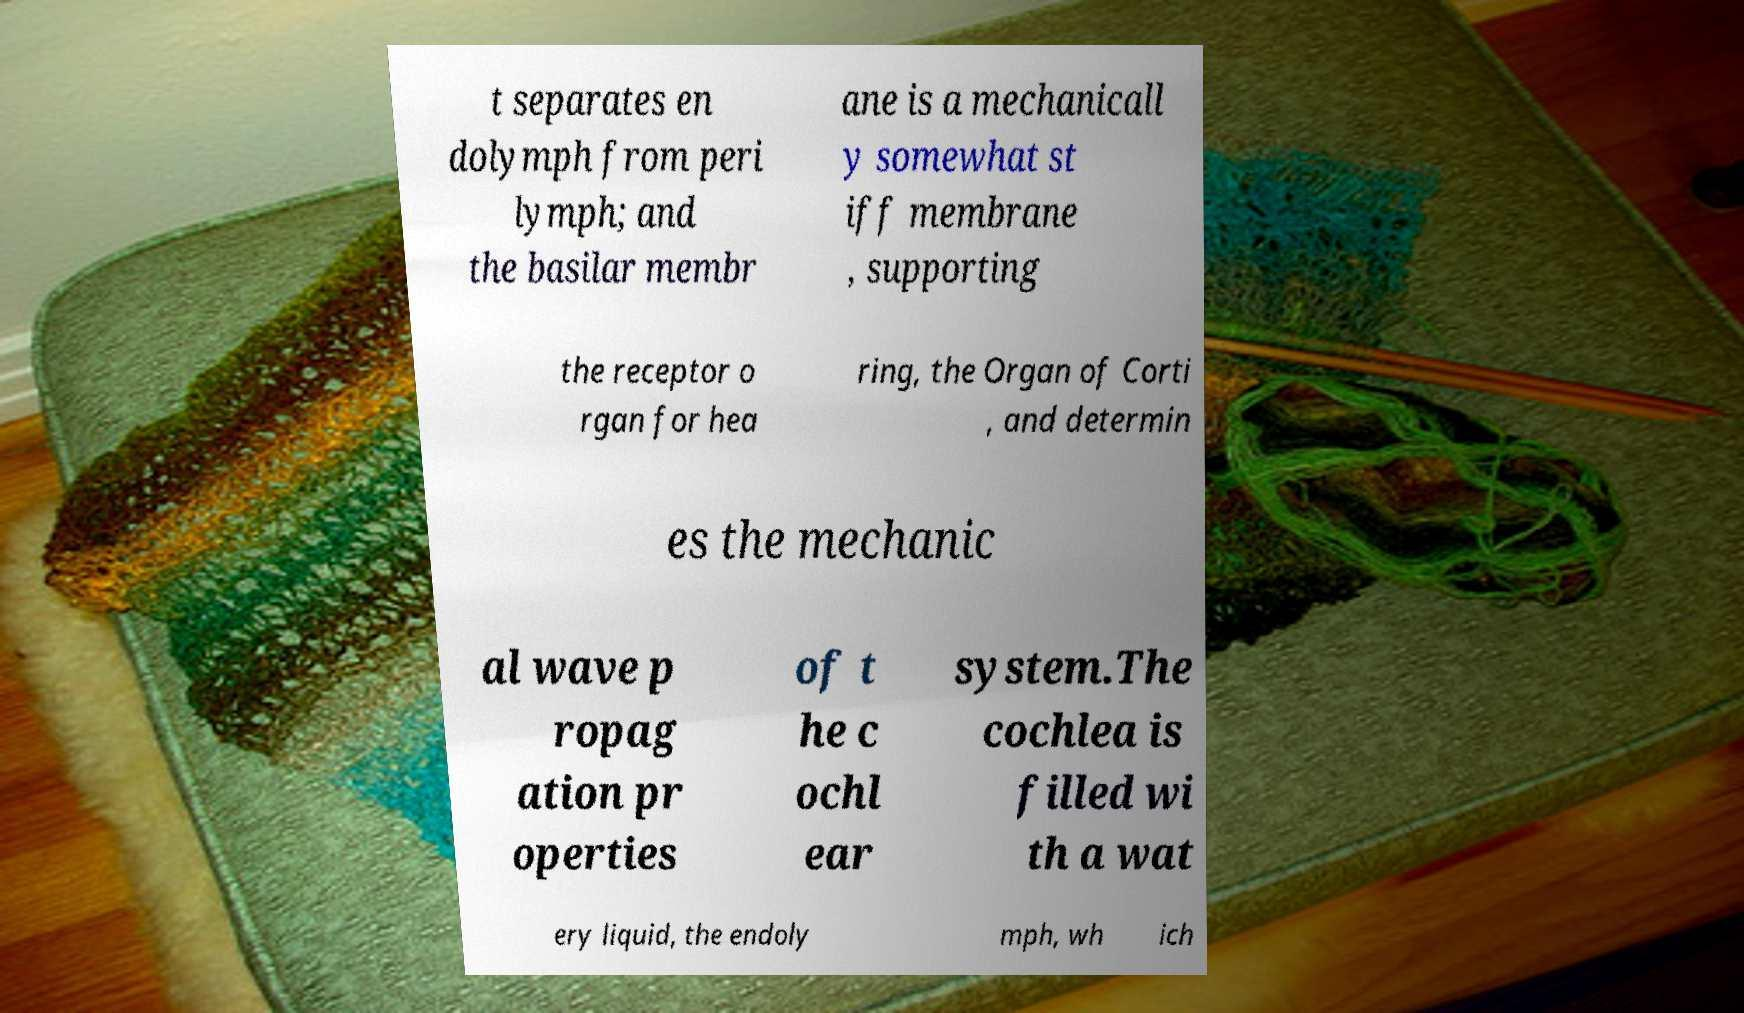For documentation purposes, I need the text within this image transcribed. Could you provide that? t separates en dolymph from peri lymph; and the basilar membr ane is a mechanicall y somewhat st iff membrane , supporting the receptor o rgan for hea ring, the Organ of Corti , and determin es the mechanic al wave p ropag ation pr operties of t he c ochl ear system.The cochlea is filled wi th a wat ery liquid, the endoly mph, wh ich 